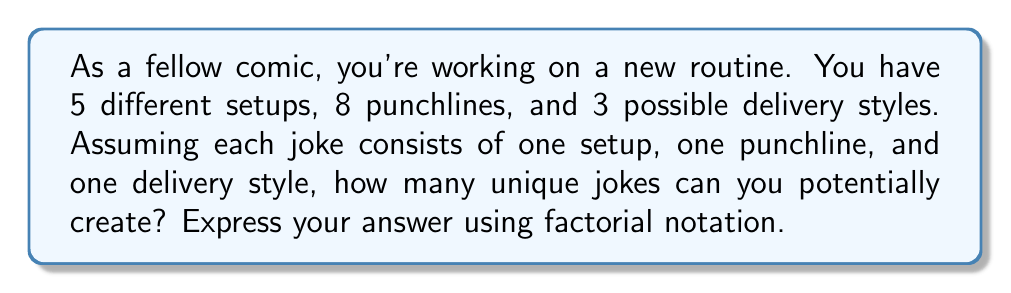Can you answer this question? Let's break this down step-by-step:

1) We have three elements to consider:
   - 5 setups
   - 8 punchlines
   - 3 delivery styles

2) For each joke, we need to choose:
   - 1 setup out of 5
   - 1 punchline out of 8
   - 1 delivery style out of 3

3) This is a perfect scenario for applying the multiplication principle of counting.

4) The number of ways to choose each element:
   - Setups: $5$ ways
   - Punchlines: $8$ ways
   - Delivery styles: $3$ ways

5) Total number of unique combinations:
   $$ 5 \times 8 \times 3 = 120 $$

6) In factorial notation, this can be expressed as:
   $$ \frac{5!}{4!} \times \frac{8!}{7!} \times \frac{3!}{2!} $$

7) Simplifying:
   $$ 5 \times 8 \times 3 = 120 $$

Therefore, you can potentially create 120 unique jokes, which can be expressed in factorial notation as $\frac{5!}{4!} \times \frac{8!}{7!} \times \frac{3!}{2!}$.
Answer: $\frac{5!}{4!} \times \frac{8!}{7!} \times \frac{3!}{2!}$ 